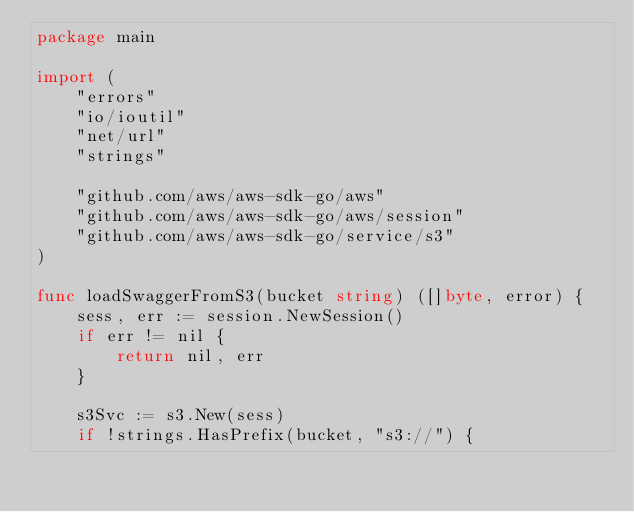Convert code to text. <code><loc_0><loc_0><loc_500><loc_500><_Go_>package main

import (
	"errors"
	"io/ioutil"
	"net/url"
	"strings"

	"github.com/aws/aws-sdk-go/aws"
	"github.com/aws/aws-sdk-go/aws/session"
	"github.com/aws/aws-sdk-go/service/s3"
)

func loadSwaggerFromS3(bucket string) ([]byte, error) {
	sess, err := session.NewSession()
	if err != nil {
		return nil, err
	}

	s3Svc := s3.New(sess)
	if !strings.HasPrefix(bucket, "s3://") {</code> 